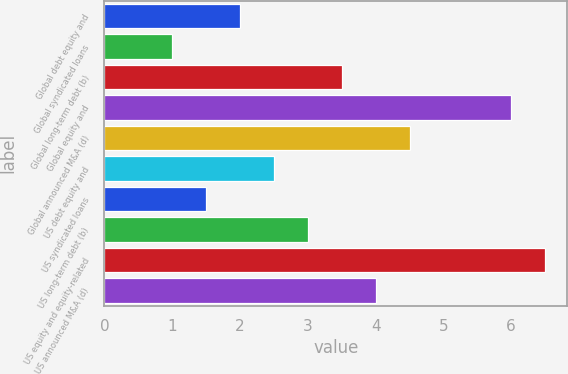<chart> <loc_0><loc_0><loc_500><loc_500><bar_chart><fcel>Global debt equity and<fcel>Global syndicated loans<fcel>Global long-term debt (b)<fcel>Global equity and<fcel>Global announced M&A (d)<fcel>US debt equity and<fcel>US syndicated loans<fcel>US long-term debt (b)<fcel>US equity and equity-related<fcel>US announced M&A (d)<nl><fcel>2<fcel>1<fcel>3.5<fcel>6<fcel>4.5<fcel>2.5<fcel>1.5<fcel>3<fcel>6.5<fcel>4<nl></chart> 